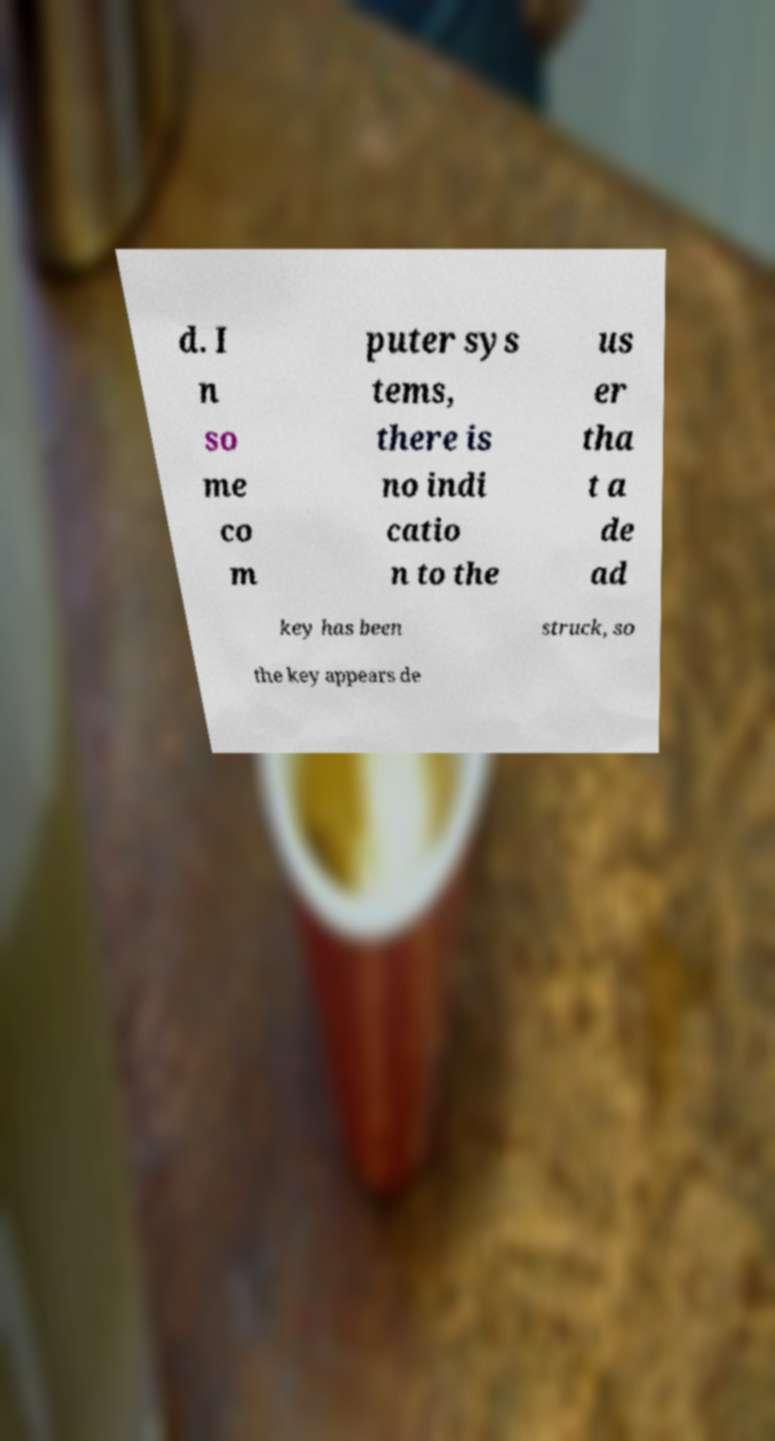What messages or text are displayed in this image? I need them in a readable, typed format. d. I n so me co m puter sys tems, there is no indi catio n to the us er tha t a de ad key has been struck, so the key appears de 